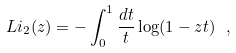Convert formula to latex. <formula><loc_0><loc_0><loc_500><loc_500>L i _ { 2 } ( z ) = - \int _ { 0 } ^ { 1 } \frac { d t } { t } \log ( 1 - z t ) \ ,</formula> 